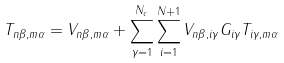<formula> <loc_0><loc_0><loc_500><loc_500>T _ { n \beta , m \alpha } = V _ { n \beta , m \alpha } + \sum _ { \gamma = 1 } ^ { N _ { c } } \sum _ { i = 1 } ^ { N + 1 } V _ { n \beta , i \gamma } G _ { i \gamma } T _ { i \gamma , m \alpha }</formula> 